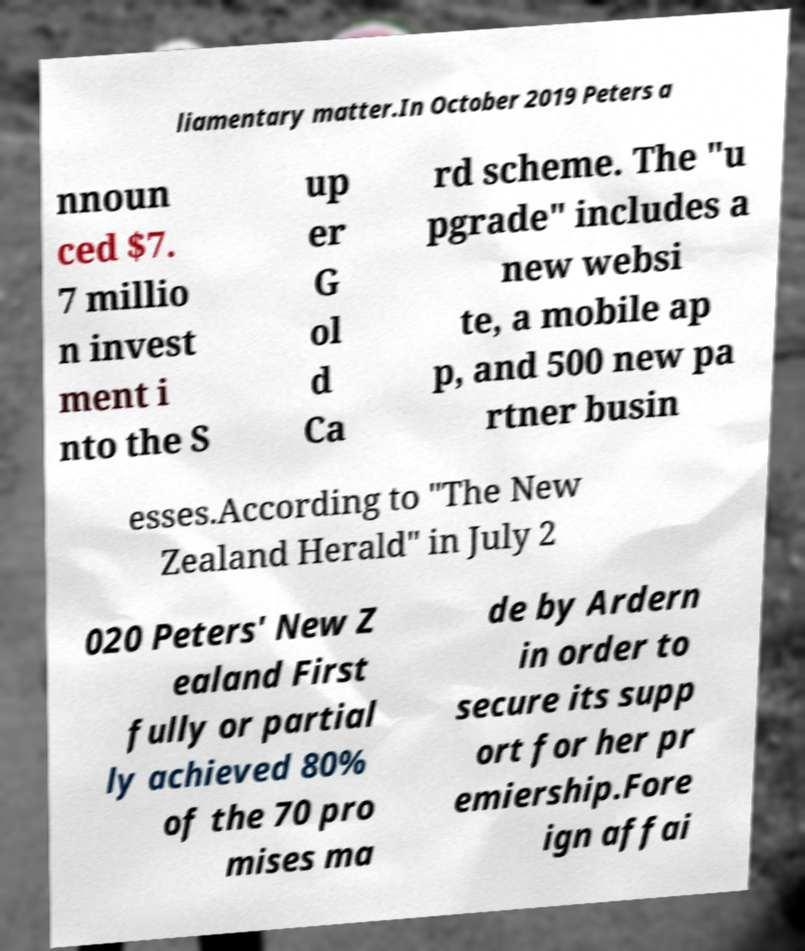Please identify and transcribe the text found in this image. liamentary matter.In October 2019 Peters a nnoun ced $7. 7 millio n invest ment i nto the S up er G ol d Ca rd scheme. The "u pgrade" includes a new websi te, a mobile ap p, and 500 new pa rtner busin esses.According to "The New Zealand Herald" in July 2 020 Peters' New Z ealand First fully or partial ly achieved 80% of the 70 pro mises ma de by Ardern in order to secure its supp ort for her pr emiership.Fore ign affai 